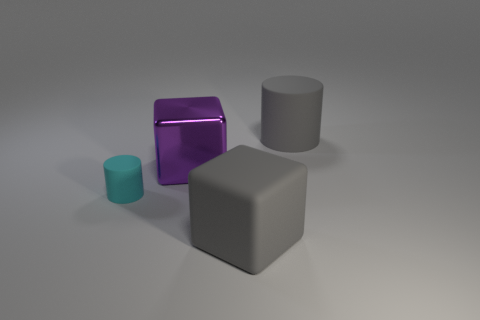If this scene were part of a video game, what kind of setting might it represent? This scene could represent a puzzle or strategy game where the blocks and cylinders might need to be moved or arranged in a certain pattern to complete a level. The minimalistic appearance suggests a modern or abstract game environment.  How could the lighting of the scene be characterized? The lighting in this scene is soft and diffuse, with gentle shadows that suggest an indoor setting with ambient light, possibly simulating a studio setup. This type of lighting creates a calm and neutral atmosphere. 